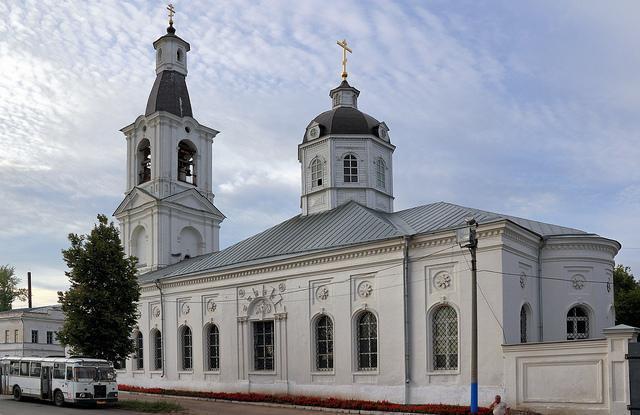How many buses are there?
Give a very brief answer. 1. How many trains are on the tracks?
Give a very brief answer. 0. 